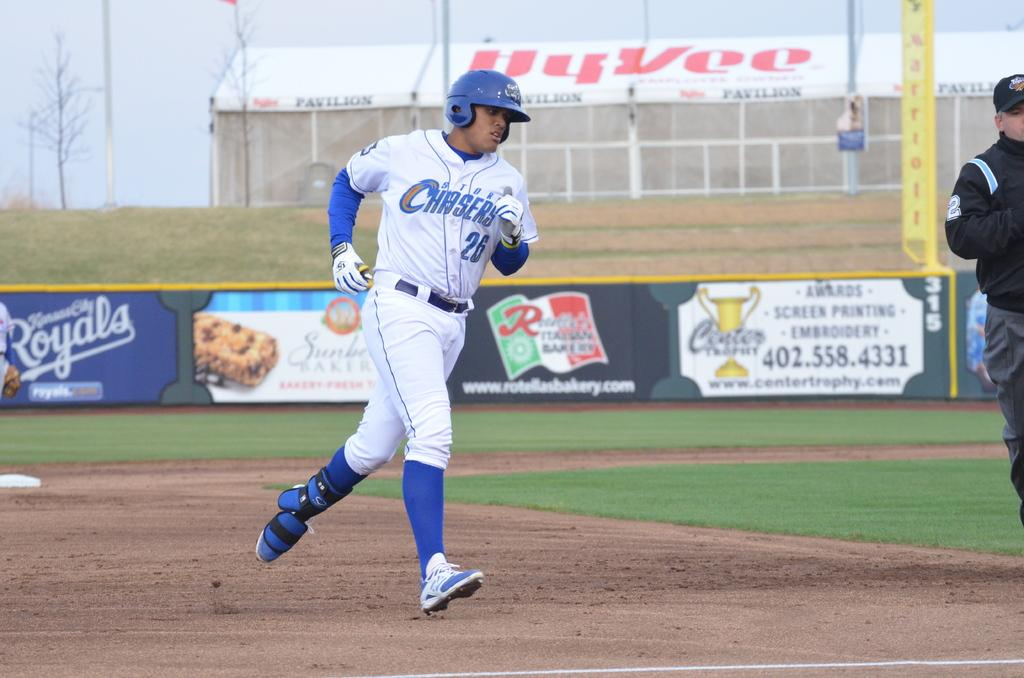<image>
Describe the image concisely. A baseball player is running for a base and his uniform says Storm Chasers 26. 